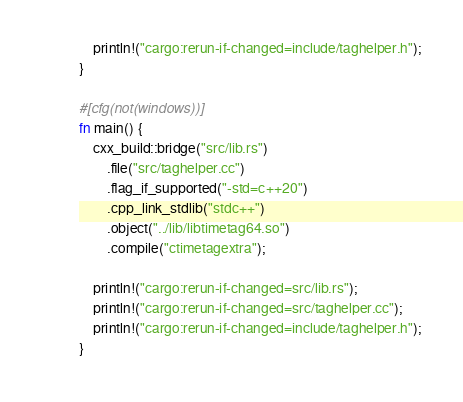Convert code to text. <code><loc_0><loc_0><loc_500><loc_500><_Rust_>    println!("cargo:rerun-if-changed=include/taghelper.h");
}

#[cfg(not(windows))]
fn main() {
    cxx_build::bridge("src/lib.rs")
        .file("src/taghelper.cc")
        .flag_if_supported("-std=c++20")
        .cpp_link_stdlib("stdc++")
        .object("../lib/libtimetag64.so")
        .compile("ctimetagextra");

    println!("cargo:rerun-if-changed=src/lib.rs");
    println!("cargo:rerun-if-changed=src/taghelper.cc");
    println!("cargo:rerun-if-changed=include/taghelper.h");
}
</code> 